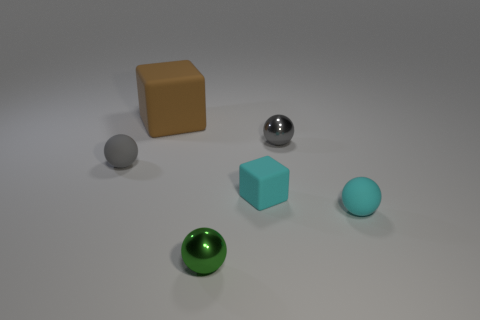Are there any tiny cubes that have the same material as the cyan sphere?
Your response must be concise. Yes. Is the small gray ball to the right of the brown matte thing made of the same material as the tiny ball that is in front of the cyan ball?
Your answer should be compact. Yes. Is the number of tiny yellow matte balls greater than the number of green metal spheres?
Your answer should be very brief. No. What color is the tiny ball on the left side of the brown cube that is behind the shiny sphere that is in front of the gray matte sphere?
Your answer should be very brief. Gray. Is the color of the cube to the left of the small green shiny sphere the same as the rubber sphere to the right of the cyan cube?
Provide a succinct answer. No. How many matte balls are behind the matte cube to the right of the small green sphere?
Your answer should be very brief. 1. Are any large brown things visible?
Make the answer very short. Yes. What number of other objects are the same color as the small matte cube?
Your answer should be compact. 1. Is the number of small cyan objects less than the number of tiny cyan spheres?
Provide a short and direct response. No. What is the shape of the object that is behind the metal sphere behind the tiny block?
Offer a very short reply. Cube. 